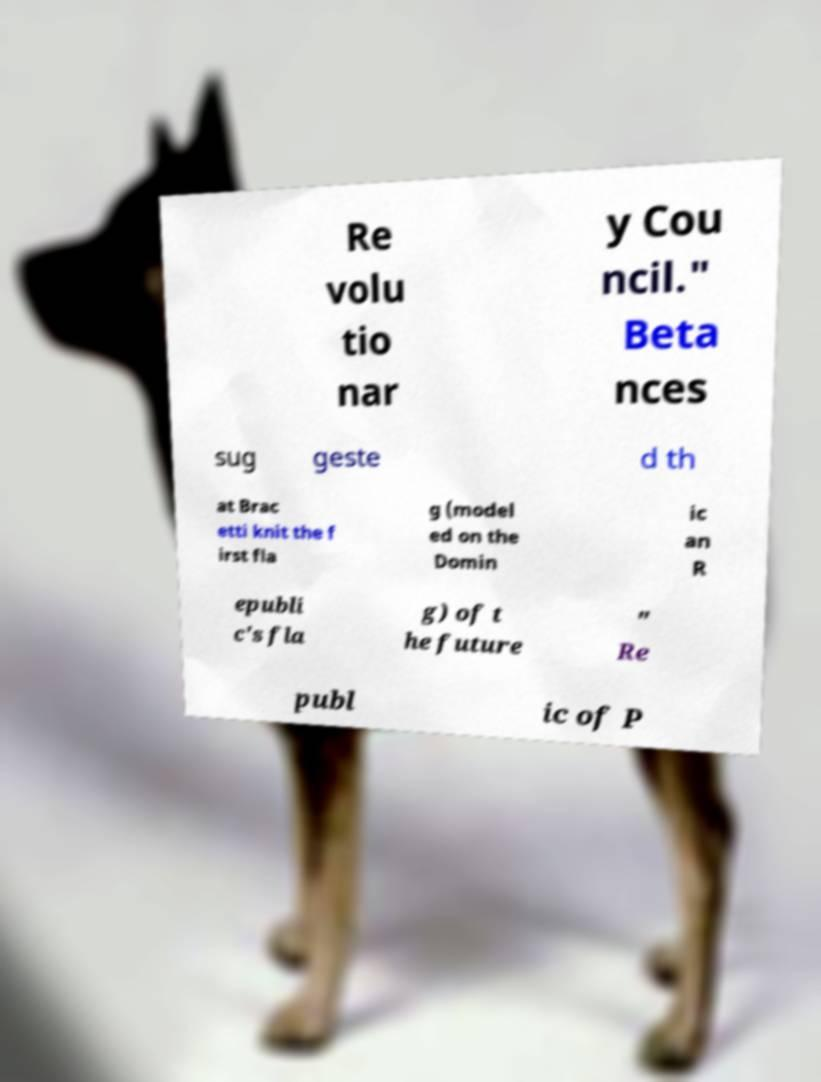Can you read and provide the text displayed in the image?This photo seems to have some interesting text. Can you extract and type it out for me? Re volu tio nar y Cou ncil." Beta nces sug geste d th at Brac etti knit the f irst fla g (model ed on the Domin ic an R epubli c's fla g) of t he future " Re publ ic of P 